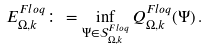Convert formula to latex. <formula><loc_0><loc_0><loc_500><loc_500>E _ { \Omega , k } ^ { F l o q } \colon = \inf _ { \Psi \in \mathcal { S } _ { \Omega , k } ^ { F l o q } } Q _ { \Omega , k } ^ { F l o q } ( \Psi ) \, .</formula> 